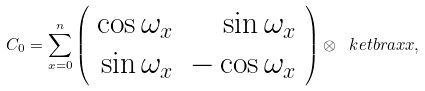<formula> <loc_0><loc_0><loc_500><loc_500>C _ { 0 } = \sum _ { x = 0 } ^ { n } \left ( \begin{array} { r r } \cos \omega _ { x } & \sin \omega _ { x } \\ \sin \omega _ { x } & - \cos \omega _ { x } \end{array} \right ) \otimes \ k e t b r a { x } { x } ,</formula> 